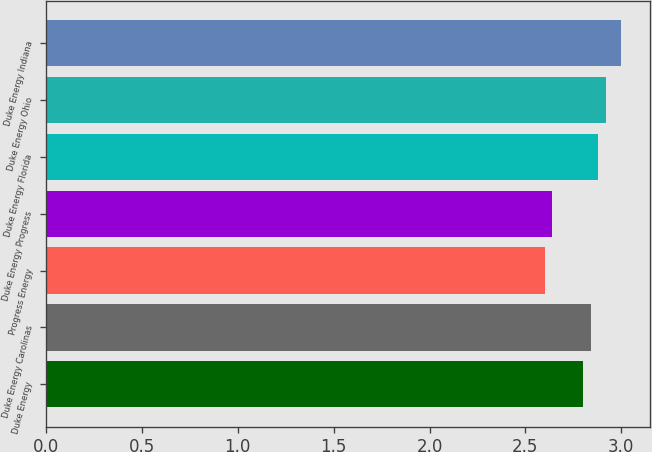Convert chart to OTSL. <chart><loc_0><loc_0><loc_500><loc_500><bar_chart><fcel>Duke Energy<fcel>Duke Energy Carolinas<fcel>Progress Energy<fcel>Duke Energy Progress<fcel>Duke Energy Florida<fcel>Duke Energy Ohio<fcel>Duke Energy Indiana<nl><fcel>2.8<fcel>2.84<fcel>2.6<fcel>2.64<fcel>2.88<fcel>2.92<fcel>3<nl></chart> 